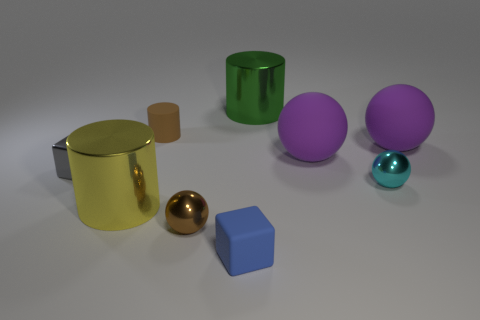Subtract all cylinders. How many objects are left? 6 Add 1 tiny things. How many tiny things are left? 6 Add 8 small brown cylinders. How many small brown cylinders exist? 9 Subtract 1 yellow cylinders. How many objects are left? 8 Subtract all yellow metallic objects. Subtract all small blue things. How many objects are left? 7 